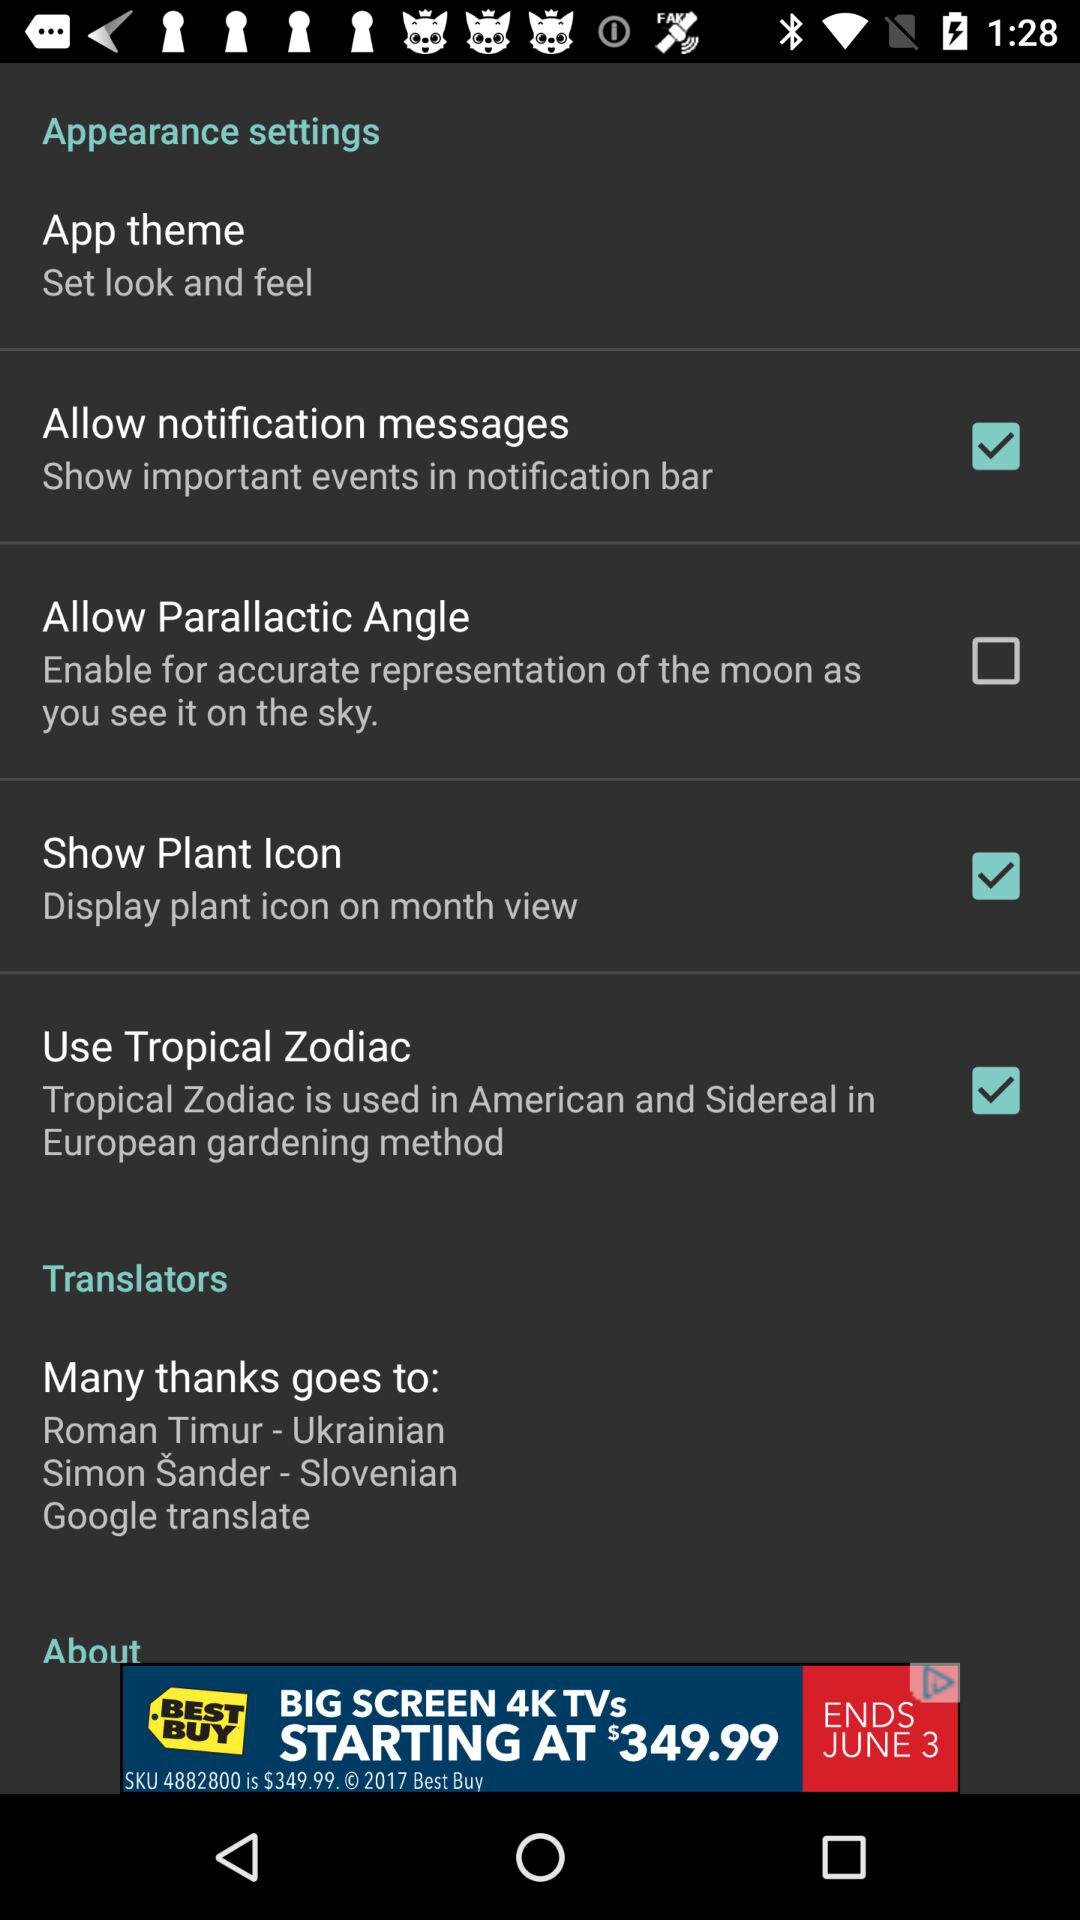Which checkbox is not checked? The checkbox that is not checked is "Allow Parallactic Angle". 